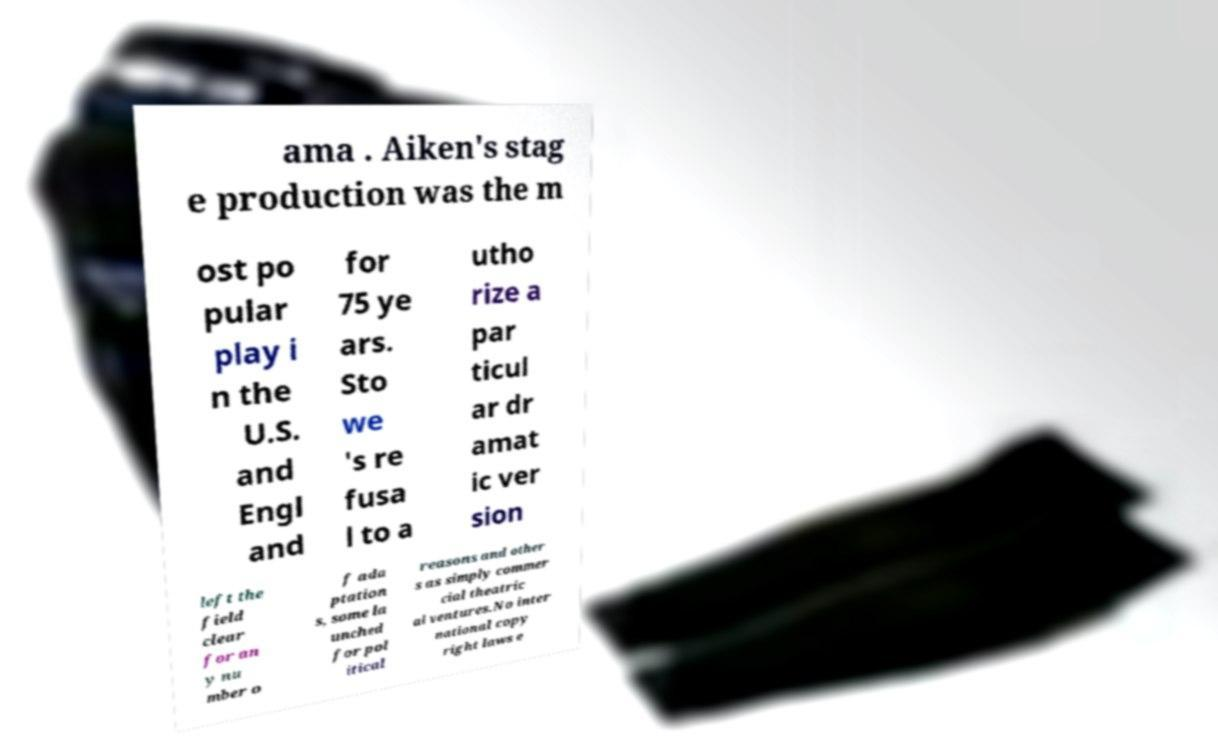Can you accurately transcribe the text from the provided image for me? ama . Aiken's stag e production was the m ost po pular play i n the U.S. and Engl and for 75 ye ars. Sto we 's re fusa l to a utho rize a par ticul ar dr amat ic ver sion left the field clear for an y nu mber o f ada ptation s, some la unched for pol itical reasons and other s as simply commer cial theatric al ventures.No inter national copy right laws e 